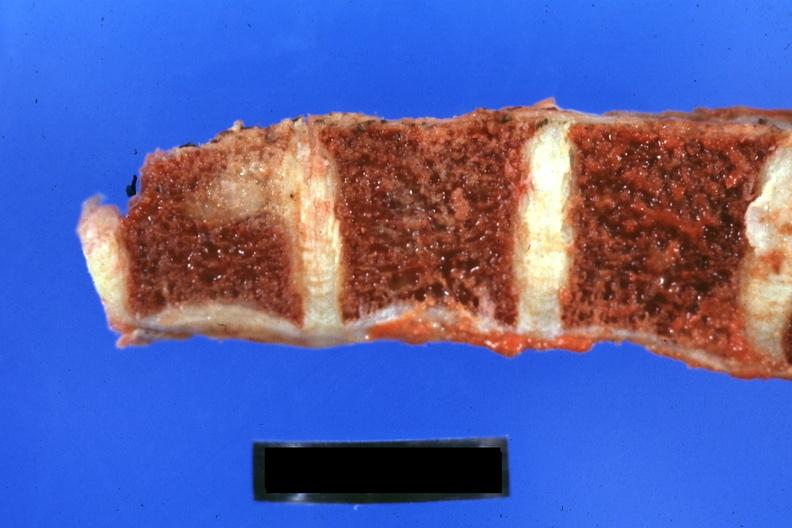what does this image show?
Answer the question using a single word or phrase. Close-up of vertebra with obvious metastatic lesion 44yobfadenocarcinoma of lung giant cell type occurring 25 years after she was treat-ed for hodgkins disease 